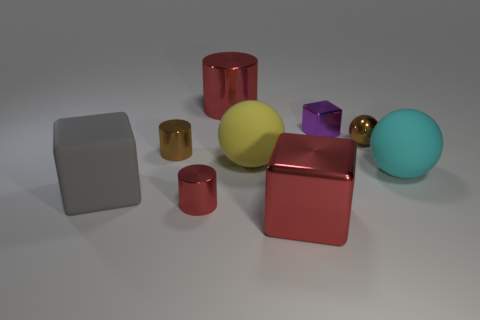There is a object that is the same color as the tiny sphere; what material is it?
Give a very brief answer. Metal. There is a tiny metal cube; does it have the same color as the large rubber ball in front of the yellow thing?
Give a very brief answer. No. What number of large red objects are in front of the brown cylinder?
Your answer should be compact. 1. Is the number of large cylinders less than the number of large cyan matte cylinders?
Offer a terse response. No. What is the size of the cylinder that is both behind the gray rubber thing and in front of the small purple metal block?
Your answer should be compact. Small. There is a tiny cylinder that is behind the yellow ball; is its color the same as the large shiny block?
Your answer should be very brief. No. Is the number of tiny brown cylinders that are right of the red shiny cube less than the number of purple shiny objects?
Keep it short and to the point. Yes. The small red thing that is made of the same material as the purple block is what shape?
Give a very brief answer. Cylinder. Is the material of the yellow ball the same as the gray block?
Ensure brevity in your answer.  Yes. Are there fewer matte objects that are behind the yellow rubber object than red shiny cylinders right of the tiny purple metallic thing?
Your answer should be compact. No. 